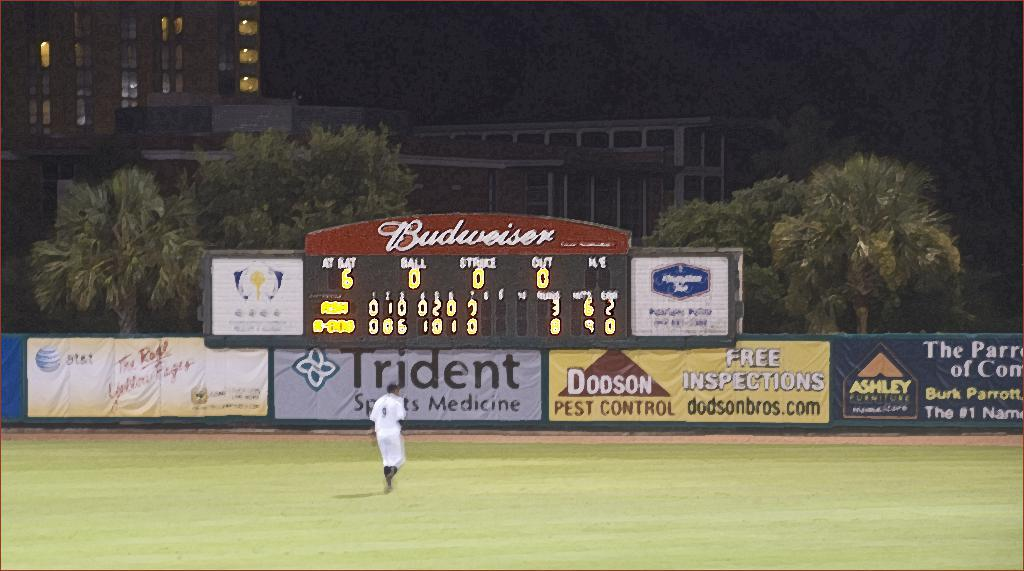<image>
Offer a succinct explanation of the picture presented. Dodson Pest Control is offering free inspections for people. 